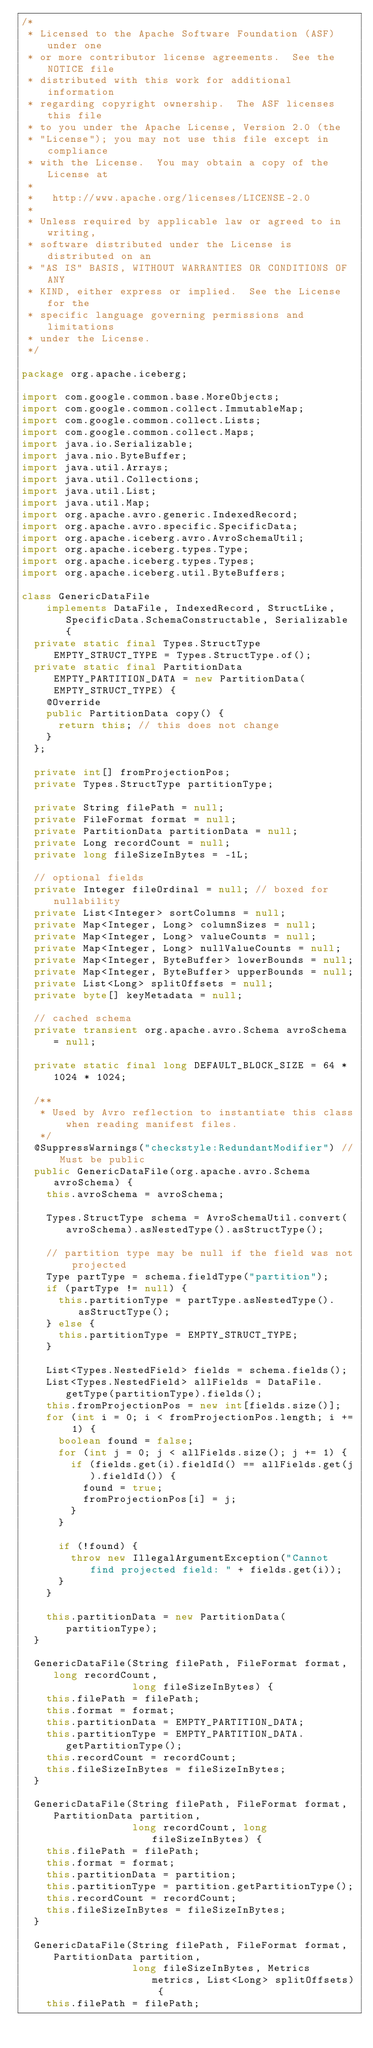<code> <loc_0><loc_0><loc_500><loc_500><_Java_>/*
 * Licensed to the Apache Software Foundation (ASF) under one
 * or more contributor license agreements.  See the NOTICE file
 * distributed with this work for additional information
 * regarding copyright ownership.  The ASF licenses this file
 * to you under the Apache License, Version 2.0 (the
 * "License"); you may not use this file except in compliance
 * with the License.  You may obtain a copy of the License at
 *
 *   http://www.apache.org/licenses/LICENSE-2.0
 *
 * Unless required by applicable law or agreed to in writing,
 * software distributed under the License is distributed on an
 * "AS IS" BASIS, WITHOUT WARRANTIES OR CONDITIONS OF ANY
 * KIND, either express or implied.  See the License for the
 * specific language governing permissions and limitations
 * under the License.
 */

package org.apache.iceberg;

import com.google.common.base.MoreObjects;
import com.google.common.collect.ImmutableMap;
import com.google.common.collect.Lists;
import com.google.common.collect.Maps;
import java.io.Serializable;
import java.nio.ByteBuffer;
import java.util.Arrays;
import java.util.Collections;
import java.util.List;
import java.util.Map;
import org.apache.avro.generic.IndexedRecord;
import org.apache.avro.specific.SpecificData;
import org.apache.iceberg.avro.AvroSchemaUtil;
import org.apache.iceberg.types.Type;
import org.apache.iceberg.types.Types;
import org.apache.iceberg.util.ByteBuffers;

class GenericDataFile
    implements DataFile, IndexedRecord, StructLike, SpecificData.SchemaConstructable, Serializable {
  private static final Types.StructType EMPTY_STRUCT_TYPE = Types.StructType.of();
  private static final PartitionData EMPTY_PARTITION_DATA = new PartitionData(EMPTY_STRUCT_TYPE) {
    @Override
    public PartitionData copy() {
      return this; // this does not change
    }
  };

  private int[] fromProjectionPos;
  private Types.StructType partitionType;

  private String filePath = null;
  private FileFormat format = null;
  private PartitionData partitionData = null;
  private Long recordCount = null;
  private long fileSizeInBytes = -1L;

  // optional fields
  private Integer fileOrdinal = null; // boxed for nullability
  private List<Integer> sortColumns = null;
  private Map<Integer, Long> columnSizes = null;
  private Map<Integer, Long> valueCounts = null;
  private Map<Integer, Long> nullValueCounts = null;
  private Map<Integer, ByteBuffer> lowerBounds = null;
  private Map<Integer, ByteBuffer> upperBounds = null;
  private List<Long> splitOffsets = null;
  private byte[] keyMetadata = null;

  // cached schema
  private transient org.apache.avro.Schema avroSchema = null;

  private static final long DEFAULT_BLOCK_SIZE = 64 * 1024 * 1024;

  /**
   * Used by Avro reflection to instantiate this class when reading manifest files.
   */
  @SuppressWarnings("checkstyle:RedundantModifier") // Must be public
  public GenericDataFile(org.apache.avro.Schema avroSchema) {
    this.avroSchema = avroSchema;

    Types.StructType schema = AvroSchemaUtil.convert(avroSchema).asNestedType().asStructType();

    // partition type may be null if the field was not projected
    Type partType = schema.fieldType("partition");
    if (partType != null) {
      this.partitionType = partType.asNestedType().asStructType();
    } else {
      this.partitionType = EMPTY_STRUCT_TYPE;
    }

    List<Types.NestedField> fields = schema.fields();
    List<Types.NestedField> allFields = DataFile.getType(partitionType).fields();
    this.fromProjectionPos = new int[fields.size()];
    for (int i = 0; i < fromProjectionPos.length; i += 1) {
      boolean found = false;
      for (int j = 0; j < allFields.size(); j += 1) {
        if (fields.get(i).fieldId() == allFields.get(j).fieldId()) {
          found = true;
          fromProjectionPos[i] = j;
        }
      }

      if (!found) {
        throw new IllegalArgumentException("Cannot find projected field: " + fields.get(i));
      }
    }

    this.partitionData = new PartitionData(partitionType);
  }

  GenericDataFile(String filePath, FileFormat format, long recordCount,
                  long fileSizeInBytes) {
    this.filePath = filePath;
    this.format = format;
    this.partitionData = EMPTY_PARTITION_DATA;
    this.partitionType = EMPTY_PARTITION_DATA.getPartitionType();
    this.recordCount = recordCount;
    this.fileSizeInBytes = fileSizeInBytes;
  }

  GenericDataFile(String filePath, FileFormat format, PartitionData partition,
                  long recordCount, long fileSizeInBytes) {
    this.filePath = filePath;
    this.format = format;
    this.partitionData = partition;
    this.partitionType = partition.getPartitionType();
    this.recordCount = recordCount;
    this.fileSizeInBytes = fileSizeInBytes;
  }

  GenericDataFile(String filePath, FileFormat format, PartitionData partition,
                  long fileSizeInBytes, Metrics metrics, List<Long> splitOffsets) {
    this.filePath = filePath;</code> 